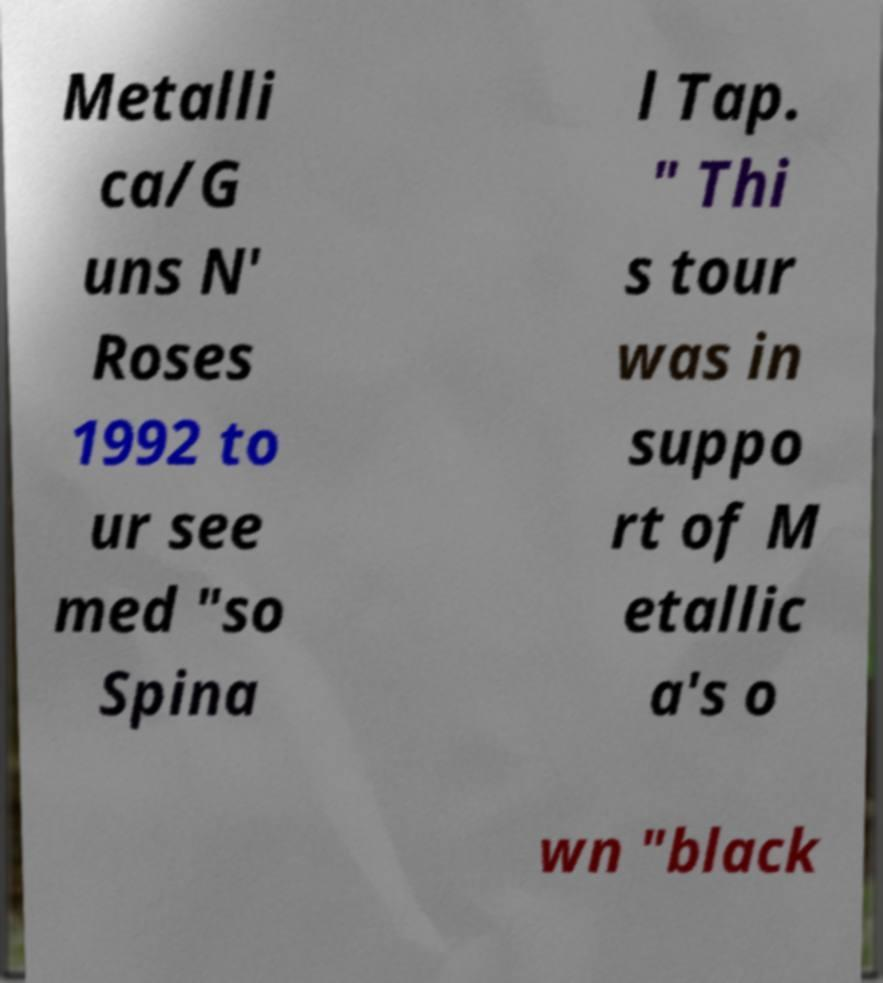Please identify and transcribe the text found in this image. Metalli ca/G uns N' Roses 1992 to ur see med "so Spina l Tap. " Thi s tour was in suppo rt of M etallic a's o wn "black 